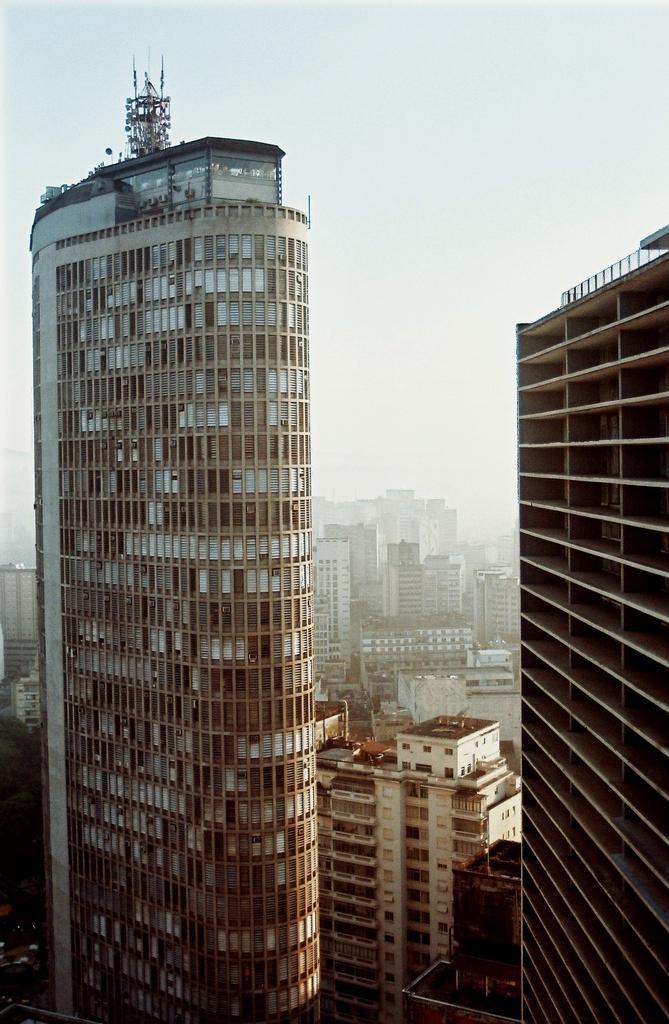Describe this image in one or two sentences. In this image I can see number of buildings and in the background I can see the sky. 